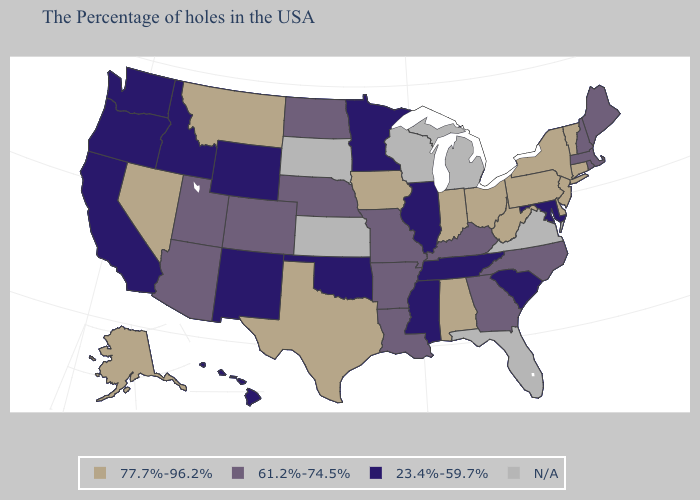What is the highest value in the West ?
Give a very brief answer. 77.7%-96.2%. What is the lowest value in the USA?
Short answer required. 23.4%-59.7%. What is the lowest value in states that border Tennessee?
Quick response, please. 23.4%-59.7%. What is the value of Alabama?
Quick response, please. 77.7%-96.2%. Does the map have missing data?
Concise answer only. Yes. What is the highest value in the USA?
Answer briefly. 77.7%-96.2%. Name the states that have a value in the range 61.2%-74.5%?
Keep it brief. Maine, Massachusetts, Rhode Island, New Hampshire, North Carolina, Georgia, Kentucky, Louisiana, Missouri, Arkansas, Nebraska, North Dakota, Colorado, Utah, Arizona. Among the states that border Idaho , does Nevada have the highest value?
Concise answer only. Yes. What is the highest value in the South ?
Write a very short answer. 77.7%-96.2%. Does the first symbol in the legend represent the smallest category?
Keep it brief. No. What is the value of Vermont?
Keep it brief. 77.7%-96.2%. Name the states that have a value in the range 77.7%-96.2%?
Concise answer only. Vermont, Connecticut, New York, New Jersey, Delaware, Pennsylvania, West Virginia, Ohio, Indiana, Alabama, Iowa, Texas, Montana, Nevada, Alaska. Name the states that have a value in the range 23.4%-59.7%?
Be succinct. Maryland, South Carolina, Tennessee, Illinois, Mississippi, Minnesota, Oklahoma, Wyoming, New Mexico, Idaho, California, Washington, Oregon, Hawaii. Name the states that have a value in the range N/A?
Quick response, please. Virginia, Florida, Michigan, Wisconsin, Kansas, South Dakota. Name the states that have a value in the range 61.2%-74.5%?
Write a very short answer. Maine, Massachusetts, Rhode Island, New Hampshire, North Carolina, Georgia, Kentucky, Louisiana, Missouri, Arkansas, Nebraska, North Dakota, Colorado, Utah, Arizona. 